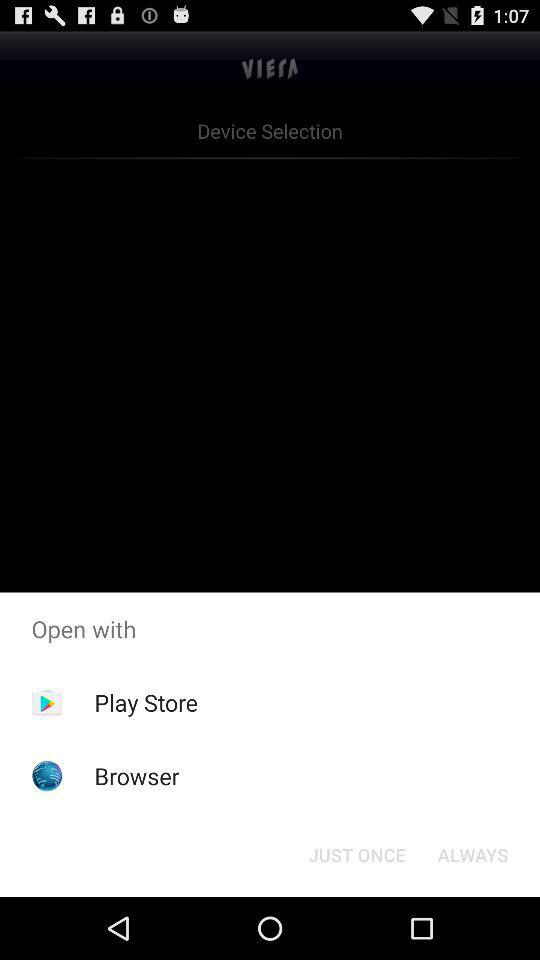What are the options to open the application? The options to open the application are "Play Store" and "Browser". 